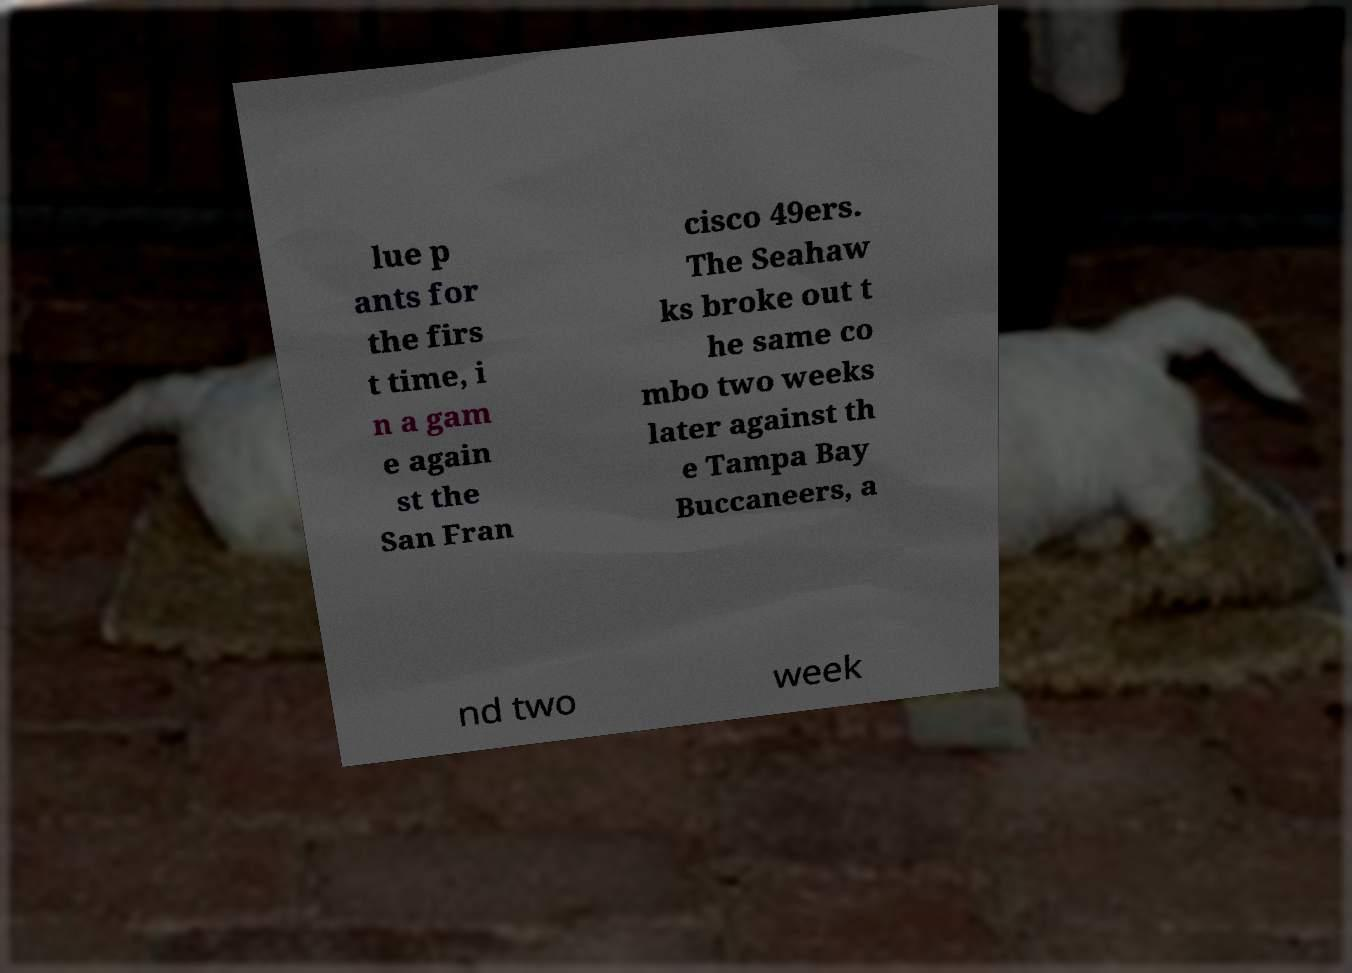I need the written content from this picture converted into text. Can you do that? lue p ants for the firs t time, i n a gam e again st the San Fran cisco 49ers. The Seahaw ks broke out t he same co mbo two weeks later against th e Tampa Bay Buccaneers, a nd two week 